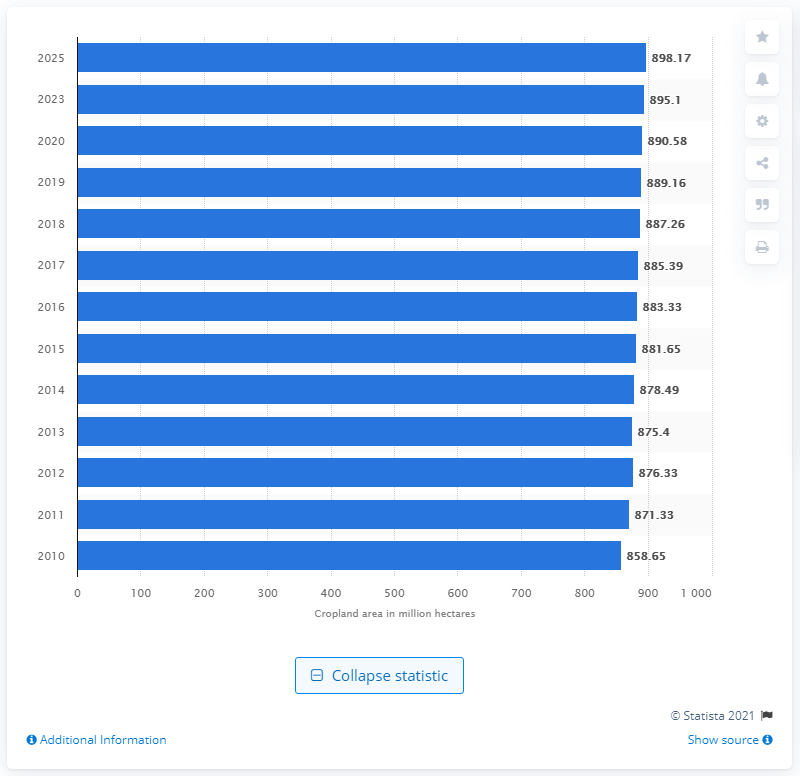Give some essential details in this illustration. By 2015, the estimated global cropland area was projected to be approximately 889.16 million hectares. 